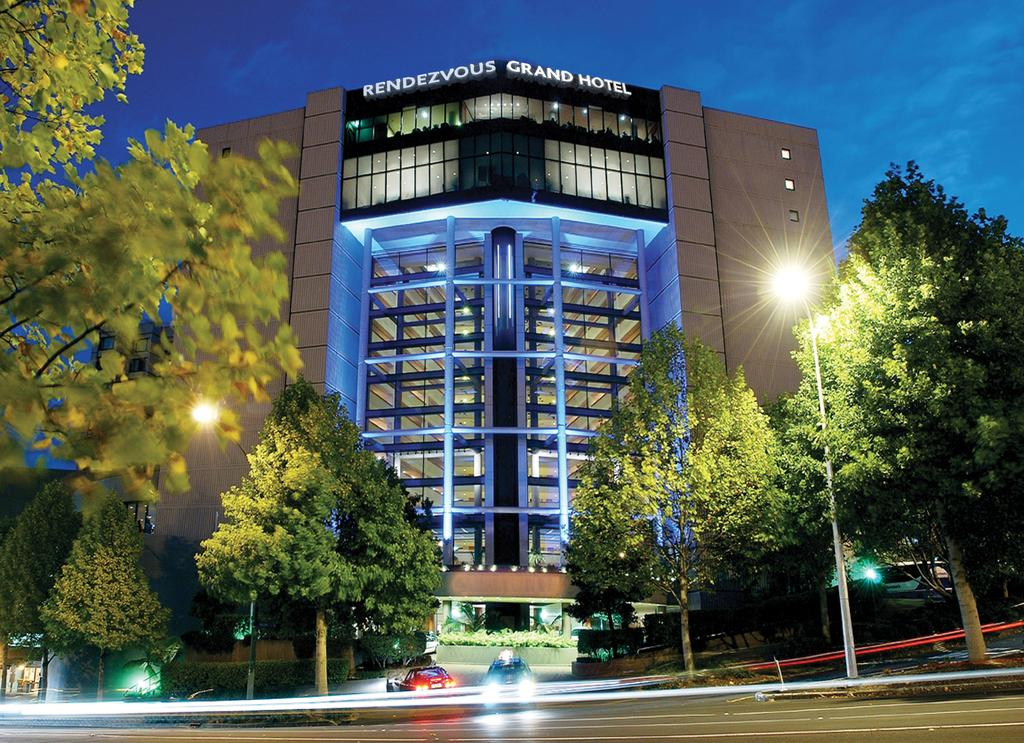What can be seen on the road in the image? There are vehicles on the road in the image. What objects are present alongside the road? There are poles in the image. What can be found on the poles? There are lights in the image. What type of structures are visible in the image? There are buildings in the image. What type of vegetation is present in the image? There are trees in the image. What is visible in the background of the image? The sky is visible in the background of the image. How many nuts are being used to fuel the vehicles in the image? There are no nuts present in the image, and vehicles do not use nuts as fuel. 